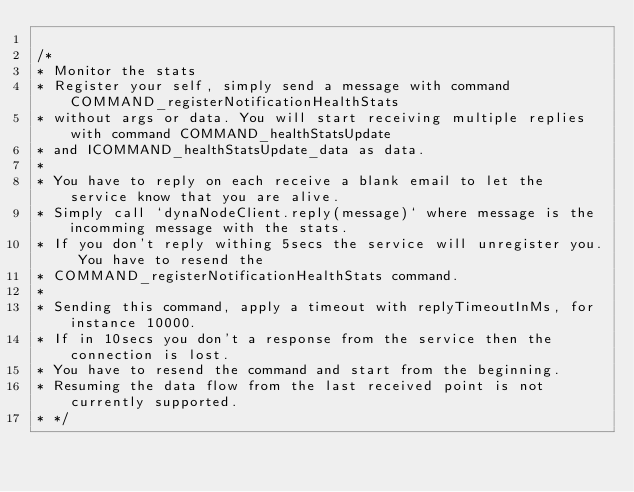Convert code to text. <code><loc_0><loc_0><loc_500><loc_500><_TypeScript_>
/*
* Monitor the stats
* Register your self, simply send a message with command COMMAND_registerNotificationHealthStats
* without args or data. You will start receiving multiple replies with command COMMAND_healthStatsUpdate
* and ICOMMAND_healthStatsUpdate_data as data.
*
* You have to reply on each receive a blank email to let the service know that you are alive.
* Simply call `dynaNodeClient.reply(message)` where message is the incomming message with the stats.
* If you don't reply withing 5secs the service will unregister you. You have to resend the
* COMMAND_registerNotificationHealthStats command.
*
* Sending this command, apply a timeout with replyTimeoutInMs, for instance 10000.
* If in 10secs you don't a response from the service then the connection is lost.
* You have to resend the command and start from the beginning.
* Resuming the data flow from the last received point is not currently supported.
* */
</code> 